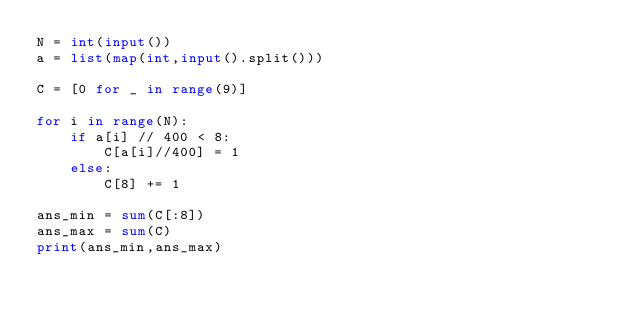<code> <loc_0><loc_0><loc_500><loc_500><_Python_>N = int(input())
a = list(map(int,input().split()))

C = [0 for _ in range(9)]

for i in range(N):
    if a[i] // 400 < 8:
        C[a[i]//400] = 1
    else:
        C[8] += 1

ans_min = sum(C[:8])
ans_max = sum(C)
print(ans_min,ans_max)
</code> 